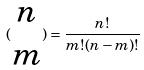<formula> <loc_0><loc_0><loc_500><loc_500>( \begin{matrix} n \\ m \end{matrix} ) = \frac { n ! } { m ! ( n - m ) ! }</formula> 